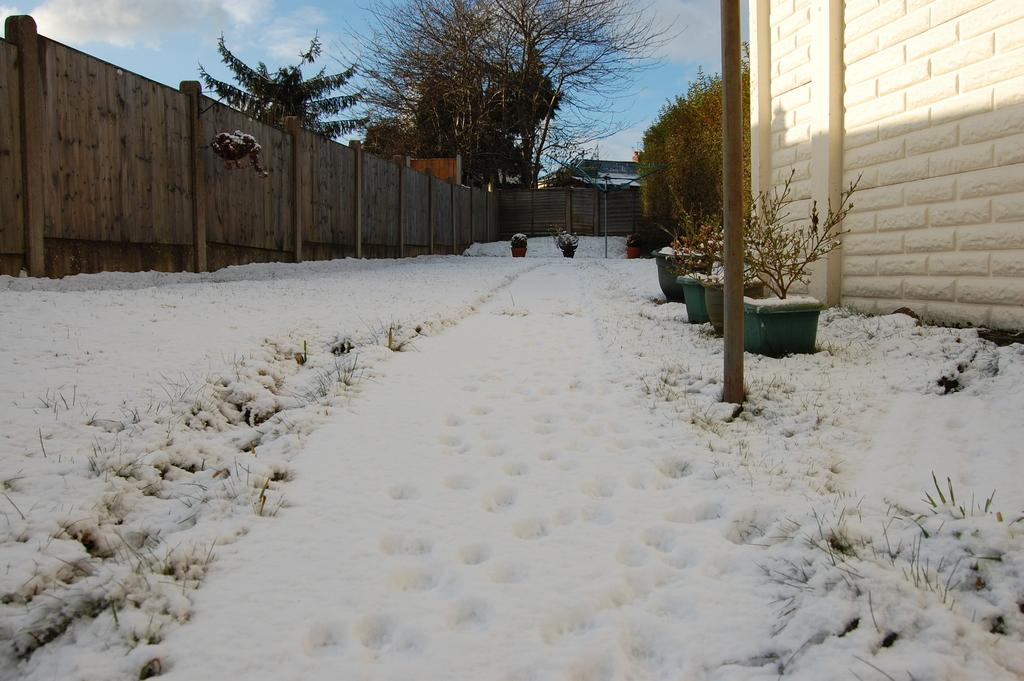What type of weather is depicted in the image? There is snow in the image, indicating a cold or wintery weather. What type of vegetation is present in the image? There is grass and plants with pots in the image. What structures can be seen in the image? There is a pole, a wall, and a fence in the image. What is visible in the background of the image? There are trees, a roof top, and the sky visible in the background of the image. What type of kitten treatment is being administered in the image? There is no kitten or any treatment visible in the image. How many beads are present on the pole in the image? There is no mention of beads on the pole in the image. 